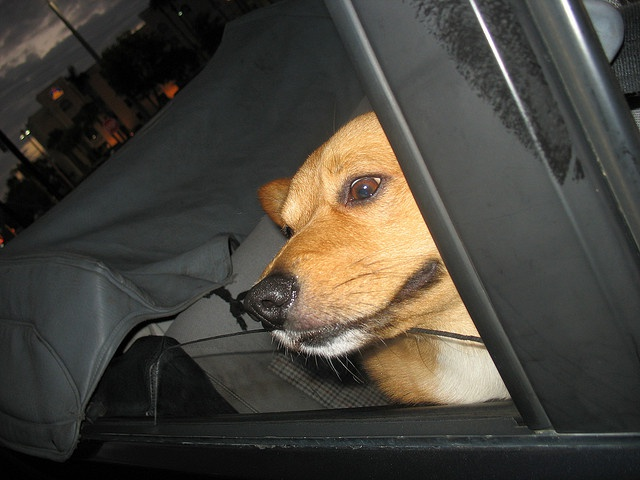Describe the objects in this image and their specific colors. I can see car in black, gray, and purple tones and dog in black, tan, and gray tones in this image. 